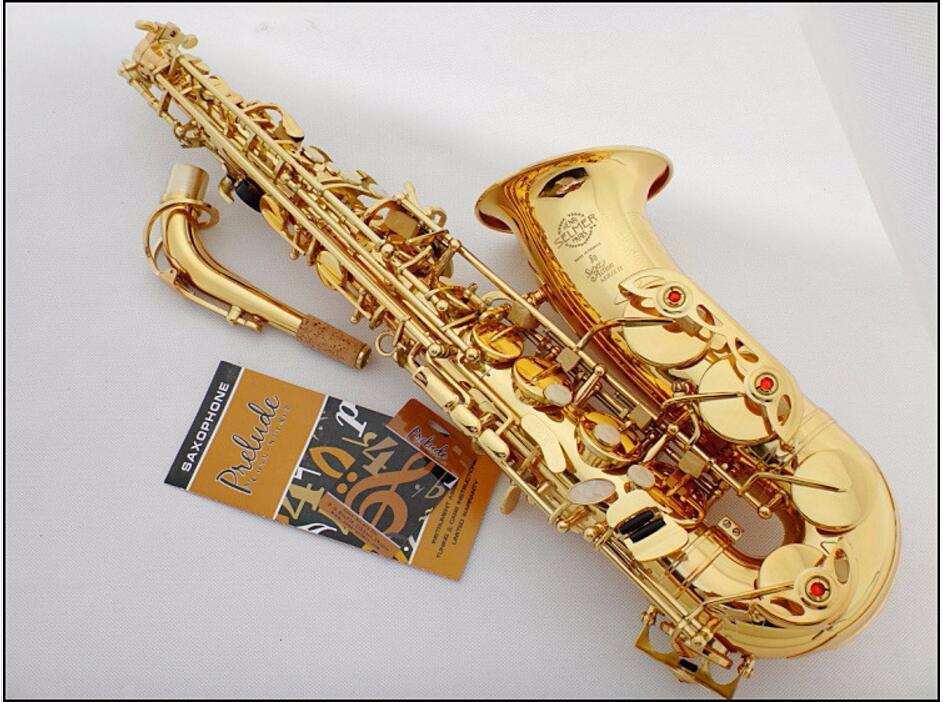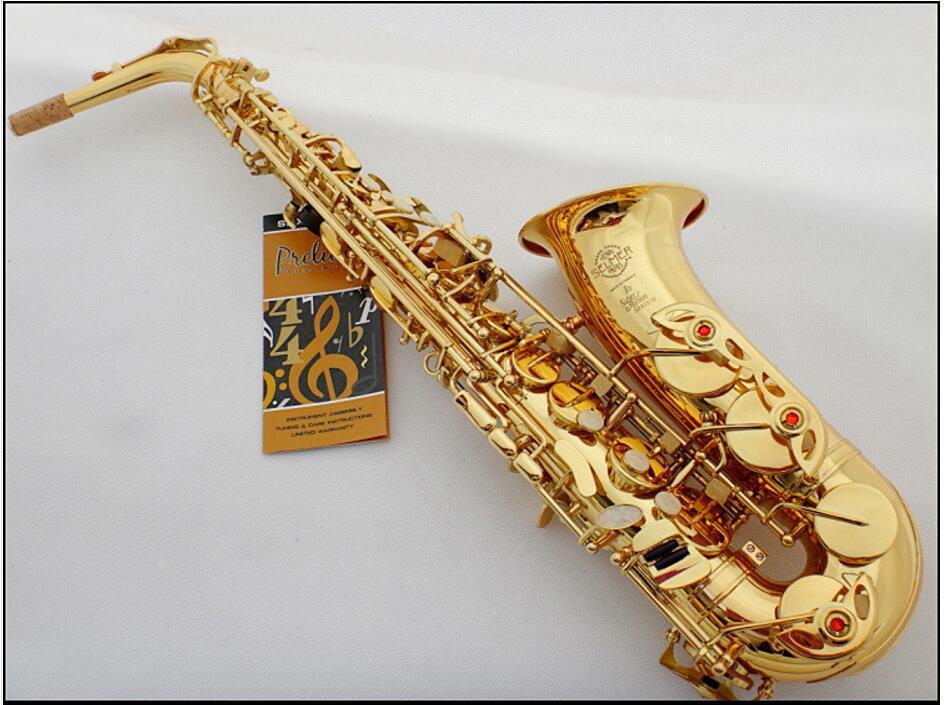The first image is the image on the left, the second image is the image on the right. Analyze the images presented: Is the assertion "A mouthpiece with a black tip is next to a gold-colored saxophone in one image." valid? Answer yes or no. No. The first image is the image on the left, the second image is the image on the right. For the images displayed, is the sentence "At least one of the images shows a booklet next to the instrument." factually correct? Answer yes or no. Yes. 